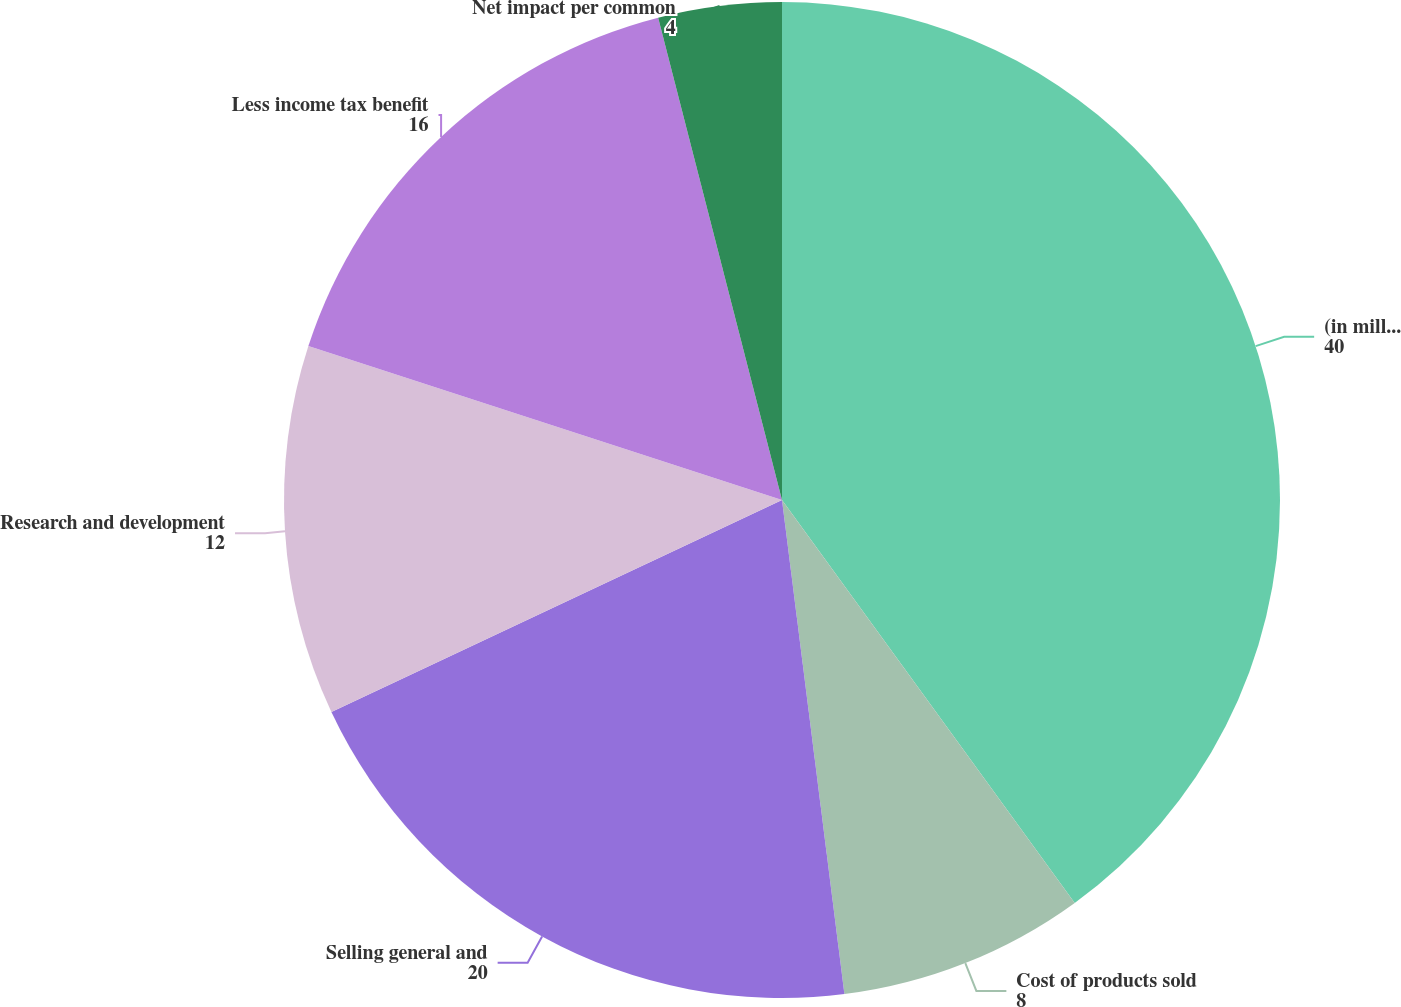Convert chart to OTSL. <chart><loc_0><loc_0><loc_500><loc_500><pie_chart><fcel>(in millions except per share<fcel>Cost of products sold<fcel>Selling general and<fcel>Research and development<fcel>Less income tax benefit<fcel>Net impact per common<nl><fcel>40.0%<fcel>8.0%<fcel>20.0%<fcel>12.0%<fcel>16.0%<fcel>4.0%<nl></chart> 